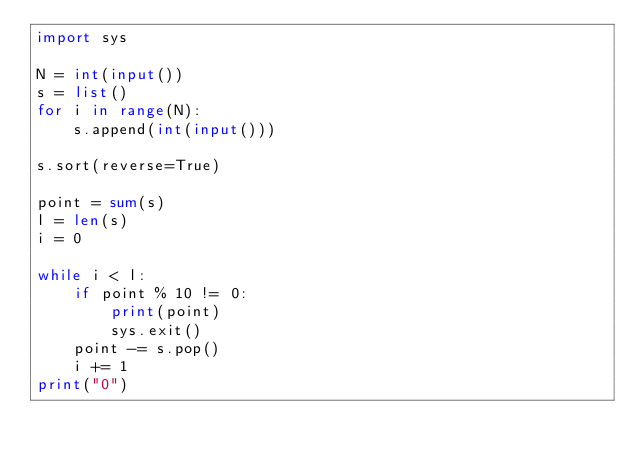<code> <loc_0><loc_0><loc_500><loc_500><_Python_>import sys

N = int(input())
s = list()
for i in range(N):
    s.append(int(input()))

s.sort(reverse=True)

point = sum(s)
l = len(s)
i = 0

while i < l:
    if point % 10 != 0:
        print(point)
        sys.exit()
    point -= s.pop()
    i += 1
print("0")</code> 